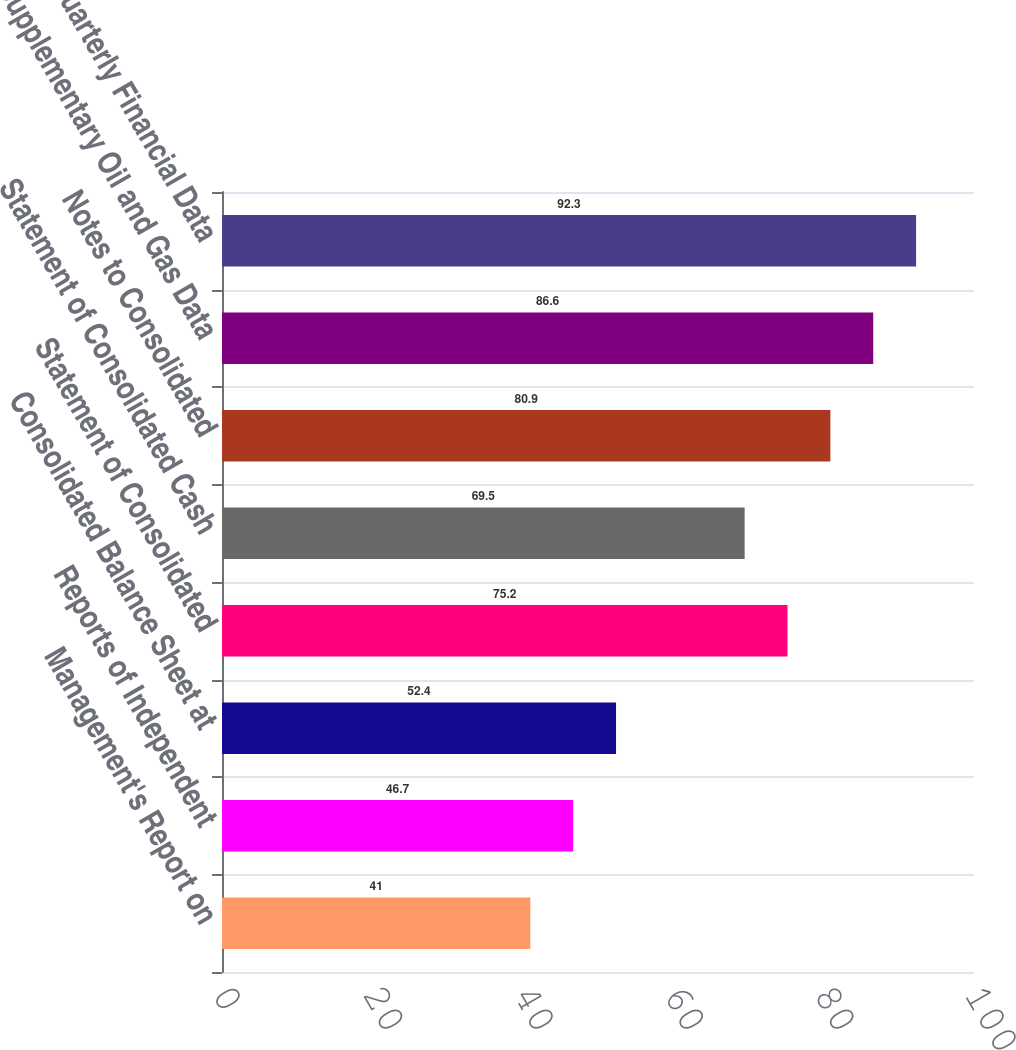Convert chart to OTSL. <chart><loc_0><loc_0><loc_500><loc_500><bar_chart><fcel>Management's Report on<fcel>Reports of Independent<fcel>Consolidated Balance Sheet at<fcel>Statement of Consolidated<fcel>Statement of Consolidated Cash<fcel>Notes to Consolidated<fcel>Supplementary Oil and Gas Data<fcel>Quarterly Financial Data<nl><fcel>41<fcel>46.7<fcel>52.4<fcel>75.2<fcel>69.5<fcel>80.9<fcel>86.6<fcel>92.3<nl></chart> 